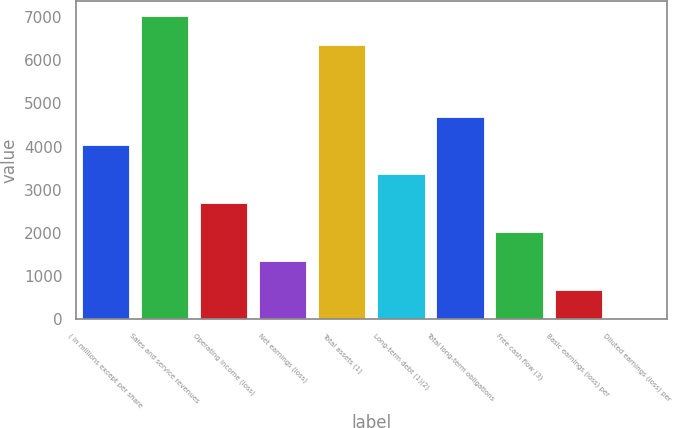Convert chart. <chart><loc_0><loc_0><loc_500><loc_500><bar_chart><fcel>( in millions except per share<fcel>Sales and service revenues<fcel>Operating income (loss)<fcel>Net earnings (loss)<fcel>Total assets (1)<fcel>Long-term debt (1)(2)<fcel>Total long-term obligations<fcel>Free cash flow (3)<fcel>Basic earnings (loss) per<fcel>Diluted earnings (loss) per<nl><fcel>4025.97<fcel>7023.51<fcel>2684.95<fcel>1343.93<fcel>6353<fcel>3355.46<fcel>4696.48<fcel>2014.44<fcel>673.42<fcel>2.91<nl></chart> 